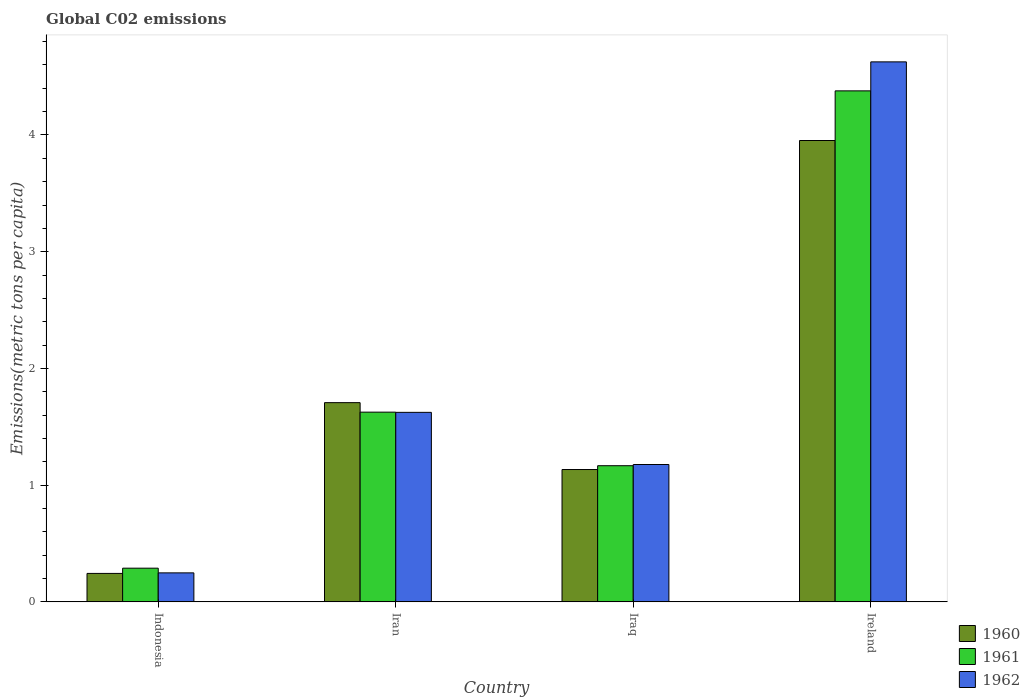How many different coloured bars are there?
Provide a short and direct response. 3. How many groups of bars are there?
Ensure brevity in your answer.  4. Are the number of bars on each tick of the X-axis equal?
Make the answer very short. Yes. How many bars are there on the 2nd tick from the right?
Make the answer very short. 3. What is the label of the 1st group of bars from the left?
Offer a very short reply. Indonesia. In how many cases, is the number of bars for a given country not equal to the number of legend labels?
Offer a very short reply. 0. What is the amount of CO2 emitted in in 1961 in Iraq?
Your answer should be compact. 1.17. Across all countries, what is the maximum amount of CO2 emitted in in 1960?
Provide a succinct answer. 3.95. Across all countries, what is the minimum amount of CO2 emitted in in 1962?
Offer a terse response. 0.25. In which country was the amount of CO2 emitted in in 1962 maximum?
Give a very brief answer. Ireland. What is the total amount of CO2 emitted in in 1962 in the graph?
Your answer should be compact. 7.68. What is the difference between the amount of CO2 emitted in in 1962 in Indonesia and that in Iran?
Keep it short and to the point. -1.38. What is the difference between the amount of CO2 emitted in in 1961 in Ireland and the amount of CO2 emitted in in 1962 in Iran?
Offer a very short reply. 2.75. What is the average amount of CO2 emitted in in 1960 per country?
Keep it short and to the point. 1.76. What is the difference between the amount of CO2 emitted in of/in 1960 and amount of CO2 emitted in of/in 1962 in Ireland?
Your answer should be compact. -0.67. What is the ratio of the amount of CO2 emitted in in 1961 in Indonesia to that in Iraq?
Your answer should be very brief. 0.25. Is the amount of CO2 emitted in in 1961 in Indonesia less than that in Ireland?
Ensure brevity in your answer.  Yes. What is the difference between the highest and the second highest amount of CO2 emitted in in 1961?
Offer a terse response. -2.75. What is the difference between the highest and the lowest amount of CO2 emitted in in 1960?
Make the answer very short. 3.71. In how many countries, is the amount of CO2 emitted in in 1961 greater than the average amount of CO2 emitted in in 1961 taken over all countries?
Make the answer very short. 1. What does the 1st bar from the left in Iraq represents?
Your answer should be very brief. 1960. Are all the bars in the graph horizontal?
Provide a short and direct response. No. How many countries are there in the graph?
Your answer should be compact. 4. What is the difference between two consecutive major ticks on the Y-axis?
Give a very brief answer. 1. Does the graph contain any zero values?
Ensure brevity in your answer.  No. Where does the legend appear in the graph?
Make the answer very short. Bottom right. How are the legend labels stacked?
Your answer should be compact. Vertical. What is the title of the graph?
Give a very brief answer. Global C02 emissions. What is the label or title of the X-axis?
Offer a terse response. Country. What is the label or title of the Y-axis?
Keep it short and to the point. Emissions(metric tons per capita). What is the Emissions(metric tons per capita) of 1960 in Indonesia?
Your answer should be very brief. 0.24. What is the Emissions(metric tons per capita) of 1961 in Indonesia?
Make the answer very short. 0.29. What is the Emissions(metric tons per capita) of 1962 in Indonesia?
Offer a terse response. 0.25. What is the Emissions(metric tons per capita) of 1960 in Iran?
Provide a succinct answer. 1.71. What is the Emissions(metric tons per capita) in 1961 in Iran?
Your response must be concise. 1.63. What is the Emissions(metric tons per capita) in 1962 in Iran?
Make the answer very short. 1.62. What is the Emissions(metric tons per capita) in 1960 in Iraq?
Offer a very short reply. 1.13. What is the Emissions(metric tons per capita) in 1961 in Iraq?
Your answer should be compact. 1.17. What is the Emissions(metric tons per capita) of 1962 in Iraq?
Your response must be concise. 1.18. What is the Emissions(metric tons per capita) in 1960 in Ireland?
Give a very brief answer. 3.95. What is the Emissions(metric tons per capita) of 1961 in Ireland?
Provide a succinct answer. 4.38. What is the Emissions(metric tons per capita) of 1962 in Ireland?
Keep it short and to the point. 4.63. Across all countries, what is the maximum Emissions(metric tons per capita) in 1960?
Give a very brief answer. 3.95. Across all countries, what is the maximum Emissions(metric tons per capita) in 1961?
Make the answer very short. 4.38. Across all countries, what is the maximum Emissions(metric tons per capita) in 1962?
Offer a terse response. 4.63. Across all countries, what is the minimum Emissions(metric tons per capita) of 1960?
Your response must be concise. 0.24. Across all countries, what is the minimum Emissions(metric tons per capita) of 1961?
Keep it short and to the point. 0.29. Across all countries, what is the minimum Emissions(metric tons per capita) in 1962?
Your response must be concise. 0.25. What is the total Emissions(metric tons per capita) in 1960 in the graph?
Keep it short and to the point. 7.04. What is the total Emissions(metric tons per capita) in 1961 in the graph?
Your answer should be compact. 7.46. What is the total Emissions(metric tons per capita) of 1962 in the graph?
Your answer should be compact. 7.68. What is the difference between the Emissions(metric tons per capita) of 1960 in Indonesia and that in Iran?
Offer a very short reply. -1.46. What is the difference between the Emissions(metric tons per capita) of 1961 in Indonesia and that in Iran?
Your answer should be very brief. -1.34. What is the difference between the Emissions(metric tons per capita) of 1962 in Indonesia and that in Iran?
Your answer should be very brief. -1.38. What is the difference between the Emissions(metric tons per capita) in 1960 in Indonesia and that in Iraq?
Your response must be concise. -0.89. What is the difference between the Emissions(metric tons per capita) of 1961 in Indonesia and that in Iraq?
Offer a terse response. -0.88. What is the difference between the Emissions(metric tons per capita) in 1962 in Indonesia and that in Iraq?
Your answer should be very brief. -0.93. What is the difference between the Emissions(metric tons per capita) of 1960 in Indonesia and that in Ireland?
Give a very brief answer. -3.71. What is the difference between the Emissions(metric tons per capita) of 1961 in Indonesia and that in Ireland?
Your answer should be compact. -4.09. What is the difference between the Emissions(metric tons per capita) in 1962 in Indonesia and that in Ireland?
Your answer should be very brief. -4.38. What is the difference between the Emissions(metric tons per capita) in 1960 in Iran and that in Iraq?
Your response must be concise. 0.57. What is the difference between the Emissions(metric tons per capita) in 1961 in Iran and that in Iraq?
Your response must be concise. 0.46. What is the difference between the Emissions(metric tons per capita) in 1962 in Iran and that in Iraq?
Offer a terse response. 0.45. What is the difference between the Emissions(metric tons per capita) of 1960 in Iran and that in Ireland?
Your response must be concise. -2.25. What is the difference between the Emissions(metric tons per capita) of 1961 in Iran and that in Ireland?
Your answer should be compact. -2.75. What is the difference between the Emissions(metric tons per capita) of 1962 in Iran and that in Ireland?
Your response must be concise. -3. What is the difference between the Emissions(metric tons per capita) of 1960 in Iraq and that in Ireland?
Keep it short and to the point. -2.82. What is the difference between the Emissions(metric tons per capita) in 1961 in Iraq and that in Ireland?
Provide a succinct answer. -3.21. What is the difference between the Emissions(metric tons per capita) in 1962 in Iraq and that in Ireland?
Your response must be concise. -3.45. What is the difference between the Emissions(metric tons per capita) in 1960 in Indonesia and the Emissions(metric tons per capita) in 1961 in Iran?
Your answer should be compact. -1.38. What is the difference between the Emissions(metric tons per capita) of 1960 in Indonesia and the Emissions(metric tons per capita) of 1962 in Iran?
Ensure brevity in your answer.  -1.38. What is the difference between the Emissions(metric tons per capita) in 1961 in Indonesia and the Emissions(metric tons per capita) in 1962 in Iran?
Your answer should be very brief. -1.33. What is the difference between the Emissions(metric tons per capita) of 1960 in Indonesia and the Emissions(metric tons per capita) of 1961 in Iraq?
Make the answer very short. -0.92. What is the difference between the Emissions(metric tons per capita) in 1960 in Indonesia and the Emissions(metric tons per capita) in 1962 in Iraq?
Ensure brevity in your answer.  -0.93. What is the difference between the Emissions(metric tons per capita) in 1961 in Indonesia and the Emissions(metric tons per capita) in 1962 in Iraq?
Provide a short and direct response. -0.89. What is the difference between the Emissions(metric tons per capita) of 1960 in Indonesia and the Emissions(metric tons per capita) of 1961 in Ireland?
Ensure brevity in your answer.  -4.13. What is the difference between the Emissions(metric tons per capita) in 1960 in Indonesia and the Emissions(metric tons per capita) in 1962 in Ireland?
Your answer should be compact. -4.38. What is the difference between the Emissions(metric tons per capita) in 1961 in Indonesia and the Emissions(metric tons per capita) in 1962 in Ireland?
Offer a very short reply. -4.34. What is the difference between the Emissions(metric tons per capita) of 1960 in Iran and the Emissions(metric tons per capita) of 1961 in Iraq?
Provide a short and direct response. 0.54. What is the difference between the Emissions(metric tons per capita) of 1960 in Iran and the Emissions(metric tons per capita) of 1962 in Iraq?
Keep it short and to the point. 0.53. What is the difference between the Emissions(metric tons per capita) of 1961 in Iran and the Emissions(metric tons per capita) of 1962 in Iraq?
Keep it short and to the point. 0.45. What is the difference between the Emissions(metric tons per capita) of 1960 in Iran and the Emissions(metric tons per capita) of 1961 in Ireland?
Give a very brief answer. -2.67. What is the difference between the Emissions(metric tons per capita) of 1960 in Iran and the Emissions(metric tons per capita) of 1962 in Ireland?
Give a very brief answer. -2.92. What is the difference between the Emissions(metric tons per capita) of 1961 in Iran and the Emissions(metric tons per capita) of 1962 in Ireland?
Offer a terse response. -3. What is the difference between the Emissions(metric tons per capita) in 1960 in Iraq and the Emissions(metric tons per capita) in 1961 in Ireland?
Your answer should be very brief. -3.24. What is the difference between the Emissions(metric tons per capita) of 1960 in Iraq and the Emissions(metric tons per capita) of 1962 in Ireland?
Provide a succinct answer. -3.49. What is the difference between the Emissions(metric tons per capita) of 1961 in Iraq and the Emissions(metric tons per capita) of 1962 in Ireland?
Provide a short and direct response. -3.46. What is the average Emissions(metric tons per capita) in 1960 per country?
Provide a succinct answer. 1.76. What is the average Emissions(metric tons per capita) in 1961 per country?
Your answer should be very brief. 1.86. What is the average Emissions(metric tons per capita) of 1962 per country?
Ensure brevity in your answer.  1.92. What is the difference between the Emissions(metric tons per capita) of 1960 and Emissions(metric tons per capita) of 1961 in Indonesia?
Keep it short and to the point. -0.04. What is the difference between the Emissions(metric tons per capita) of 1960 and Emissions(metric tons per capita) of 1962 in Indonesia?
Keep it short and to the point. -0. What is the difference between the Emissions(metric tons per capita) in 1961 and Emissions(metric tons per capita) in 1962 in Indonesia?
Provide a succinct answer. 0.04. What is the difference between the Emissions(metric tons per capita) in 1960 and Emissions(metric tons per capita) in 1961 in Iran?
Your answer should be very brief. 0.08. What is the difference between the Emissions(metric tons per capita) of 1960 and Emissions(metric tons per capita) of 1962 in Iran?
Your answer should be compact. 0.08. What is the difference between the Emissions(metric tons per capita) of 1961 and Emissions(metric tons per capita) of 1962 in Iran?
Keep it short and to the point. 0. What is the difference between the Emissions(metric tons per capita) in 1960 and Emissions(metric tons per capita) in 1961 in Iraq?
Offer a terse response. -0.03. What is the difference between the Emissions(metric tons per capita) of 1960 and Emissions(metric tons per capita) of 1962 in Iraq?
Provide a succinct answer. -0.04. What is the difference between the Emissions(metric tons per capita) of 1961 and Emissions(metric tons per capita) of 1962 in Iraq?
Make the answer very short. -0.01. What is the difference between the Emissions(metric tons per capita) in 1960 and Emissions(metric tons per capita) in 1961 in Ireland?
Give a very brief answer. -0.43. What is the difference between the Emissions(metric tons per capita) in 1960 and Emissions(metric tons per capita) in 1962 in Ireland?
Provide a succinct answer. -0.67. What is the difference between the Emissions(metric tons per capita) in 1961 and Emissions(metric tons per capita) in 1962 in Ireland?
Offer a very short reply. -0.25. What is the ratio of the Emissions(metric tons per capita) of 1960 in Indonesia to that in Iran?
Your answer should be very brief. 0.14. What is the ratio of the Emissions(metric tons per capita) of 1961 in Indonesia to that in Iran?
Make the answer very short. 0.18. What is the ratio of the Emissions(metric tons per capita) of 1962 in Indonesia to that in Iran?
Provide a succinct answer. 0.15. What is the ratio of the Emissions(metric tons per capita) of 1960 in Indonesia to that in Iraq?
Your response must be concise. 0.21. What is the ratio of the Emissions(metric tons per capita) in 1961 in Indonesia to that in Iraq?
Your response must be concise. 0.25. What is the ratio of the Emissions(metric tons per capita) of 1962 in Indonesia to that in Iraq?
Provide a short and direct response. 0.21. What is the ratio of the Emissions(metric tons per capita) of 1960 in Indonesia to that in Ireland?
Keep it short and to the point. 0.06. What is the ratio of the Emissions(metric tons per capita) in 1961 in Indonesia to that in Ireland?
Keep it short and to the point. 0.07. What is the ratio of the Emissions(metric tons per capita) of 1962 in Indonesia to that in Ireland?
Your answer should be very brief. 0.05. What is the ratio of the Emissions(metric tons per capita) of 1960 in Iran to that in Iraq?
Your answer should be very brief. 1.51. What is the ratio of the Emissions(metric tons per capita) in 1961 in Iran to that in Iraq?
Your answer should be compact. 1.39. What is the ratio of the Emissions(metric tons per capita) in 1962 in Iran to that in Iraq?
Ensure brevity in your answer.  1.38. What is the ratio of the Emissions(metric tons per capita) of 1960 in Iran to that in Ireland?
Keep it short and to the point. 0.43. What is the ratio of the Emissions(metric tons per capita) in 1961 in Iran to that in Ireland?
Offer a terse response. 0.37. What is the ratio of the Emissions(metric tons per capita) in 1962 in Iran to that in Ireland?
Provide a succinct answer. 0.35. What is the ratio of the Emissions(metric tons per capita) of 1960 in Iraq to that in Ireland?
Ensure brevity in your answer.  0.29. What is the ratio of the Emissions(metric tons per capita) in 1961 in Iraq to that in Ireland?
Your response must be concise. 0.27. What is the ratio of the Emissions(metric tons per capita) in 1962 in Iraq to that in Ireland?
Give a very brief answer. 0.25. What is the difference between the highest and the second highest Emissions(metric tons per capita) of 1960?
Ensure brevity in your answer.  2.25. What is the difference between the highest and the second highest Emissions(metric tons per capita) of 1961?
Make the answer very short. 2.75. What is the difference between the highest and the second highest Emissions(metric tons per capita) of 1962?
Give a very brief answer. 3. What is the difference between the highest and the lowest Emissions(metric tons per capita) in 1960?
Give a very brief answer. 3.71. What is the difference between the highest and the lowest Emissions(metric tons per capita) in 1961?
Your answer should be compact. 4.09. What is the difference between the highest and the lowest Emissions(metric tons per capita) in 1962?
Give a very brief answer. 4.38. 